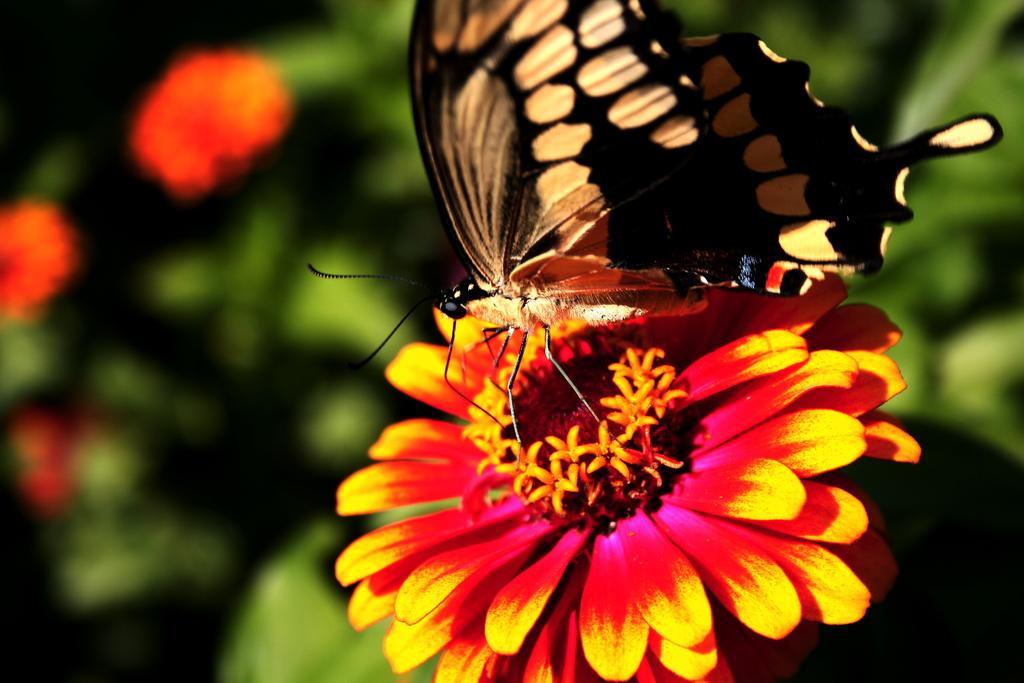Please provide a concise description of this image. In this image there is a butterfly on a flower, in the background of the image there are flowers and leaves. 